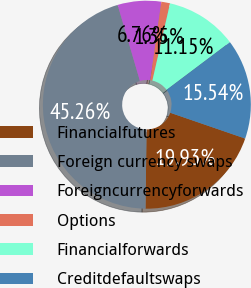Convert chart to OTSL. <chart><loc_0><loc_0><loc_500><loc_500><pie_chart><fcel>Financialfutures<fcel>Foreign currency swaps<fcel>Foreigncurrencyforwards<fcel>Options<fcel>Financialforwards<fcel>Creditdefaultswaps<nl><fcel>19.93%<fcel>45.25%<fcel>6.76%<fcel>1.35%<fcel>11.15%<fcel>15.54%<nl></chart> 